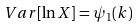<formula> <loc_0><loc_0><loc_500><loc_500>V a r [ \ln X ] = \psi _ { 1 } ( k )</formula> 